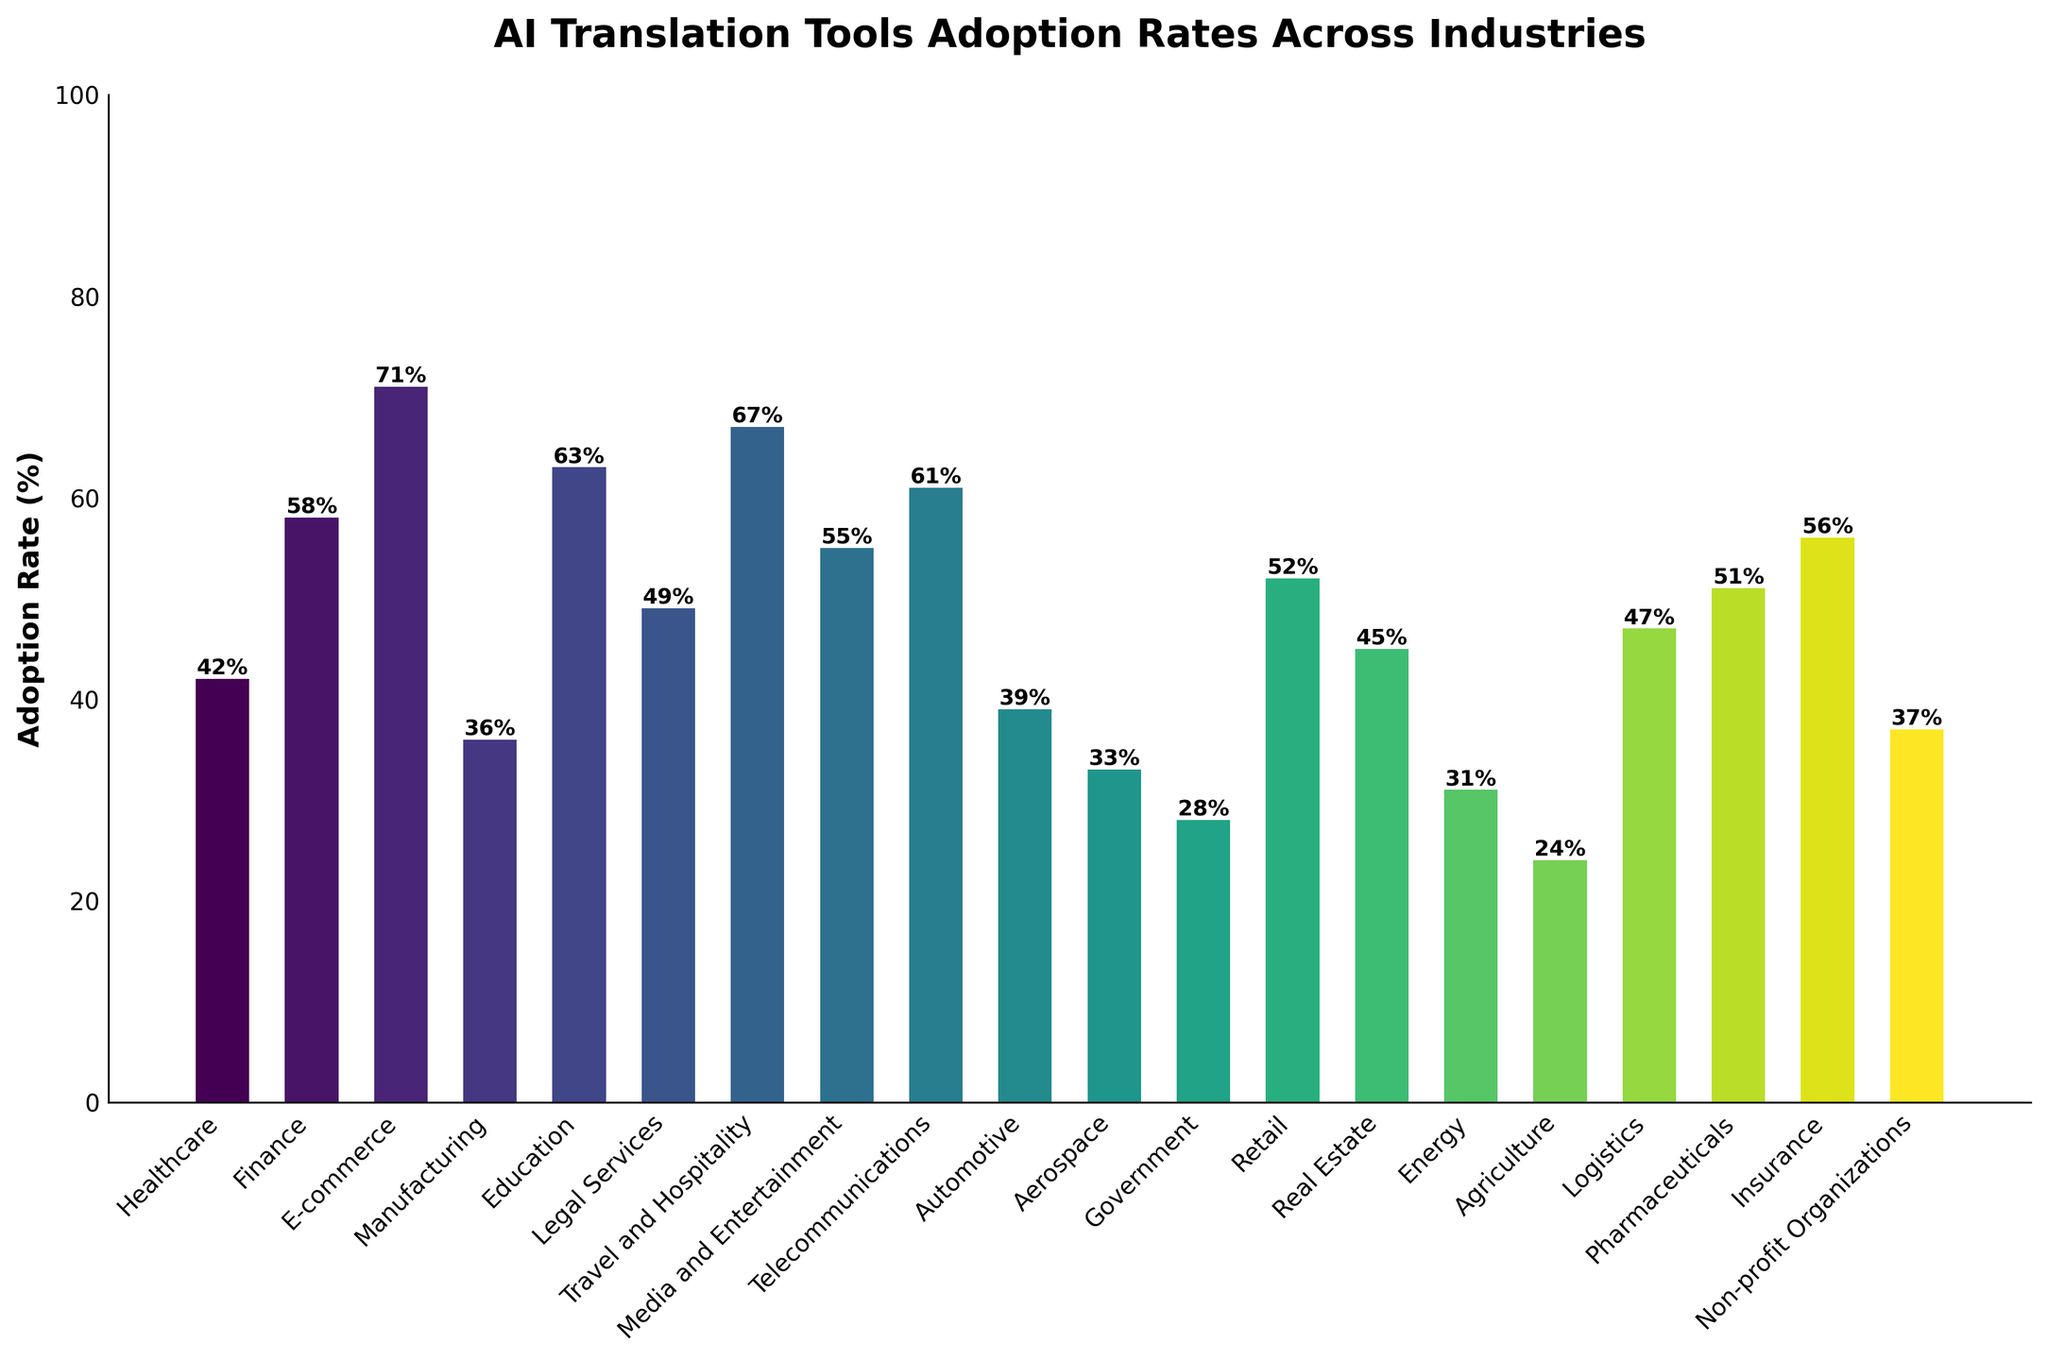Which industry has the highest adoption rate of AI translation tools? Locate the bar with the highest height and the corresponding industry. The highest bar represents the industry with the highest adoption rate.
Answer: E-commerce Which industry has the lowest adoption rate of AI translation tools? Locate the bar with the lowest height and the corresponding industry. The lowest bar represents the industry with the lowest adoption rate.
Answer: Agriculture What is the difference in adoption rates between the Finance and Government industries? Identify the heights of the bars corresponding to the Finance and Government industries. Subtract the adoption rate of Government (28%) from the adoption rate of Finance (58%).
Answer: 30% How many industries have an adoption rate above 50%? Count the number of bars that have heights above the 50% mark on the y-axis.
Answer: 10 Which industry has an adoption rate closest to the average adoption rate across all industries? First, calculate the average adoption rate: Sum all adoption rates and divide by the number of industries. Then find the industry with an adoption rate closest to this average.
Answer: Media and Entertainment, with an adoption rate of 55% Compare the adoption rates of Healthcare and Manufacturing industries. Which one is higher and by how much? Identify the heights of the bars for Healthcare (42%) and Manufacturing (36%). Subtract the adoption rate of Manufacturing from Healthcare.
Answer: Healthcare by 6% What is the combined adoption rate of the top three industries with the highest adoption rates? Identify the top three industries with the highest bars, then sum their adoption rates (E-commerce 71%, Travel and Hospitality 67%, and Education 63%).
Answer: 201% Which industries have adoption rates below 40%? Identify the bars that have heights below the 40% mark on the y-axis and list the corresponding industries.
Answer: Manufacturing, Automotive, Aerospace, Government, Energy, Agriculture What is the average adoption rate of AI translation tools across all industries? Sum all the adoption rates and divide by the number of industries (20). Sum = 946, Average = 946/20.
Answer: 47.3% Which industries have adoption rates between 40% and 60%? Identify the bars that have heights between the 40% and 60% marks on the y-axis and list the corresponding industries.
Answer: Healthcare, Finance, Legal Services, Media and Entertainment, Telecommunications, Automotive, Retail, Real Estate, Logistics, Pharmaceuticals, Insurance 